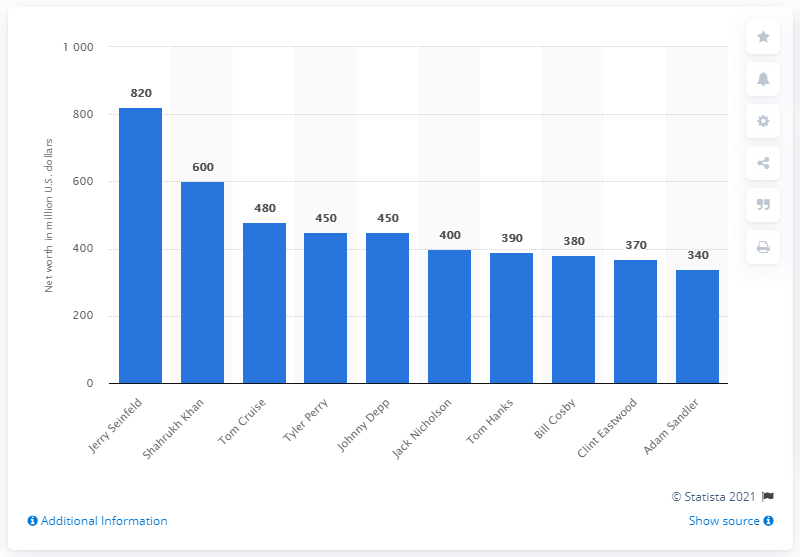Point out several critical features in this image. According to a ranking, Tom Hanks ranked seventh with a net worth of 390 million U.S. dollars. 